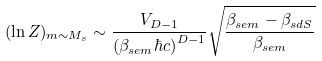Convert formula to latex. <formula><loc_0><loc_0><loc_500><loc_500>( \ln Z ) _ { m \sim M _ { s } } \sim \frac { V _ { D - 1 } } { \left ( \beta _ { s e m } \hbar { c } \right ) ^ { D - 1 } } \sqrt { \frac { \beta _ { s e m } - \beta _ { s d S } } { \beta _ { s e m } } }</formula> 